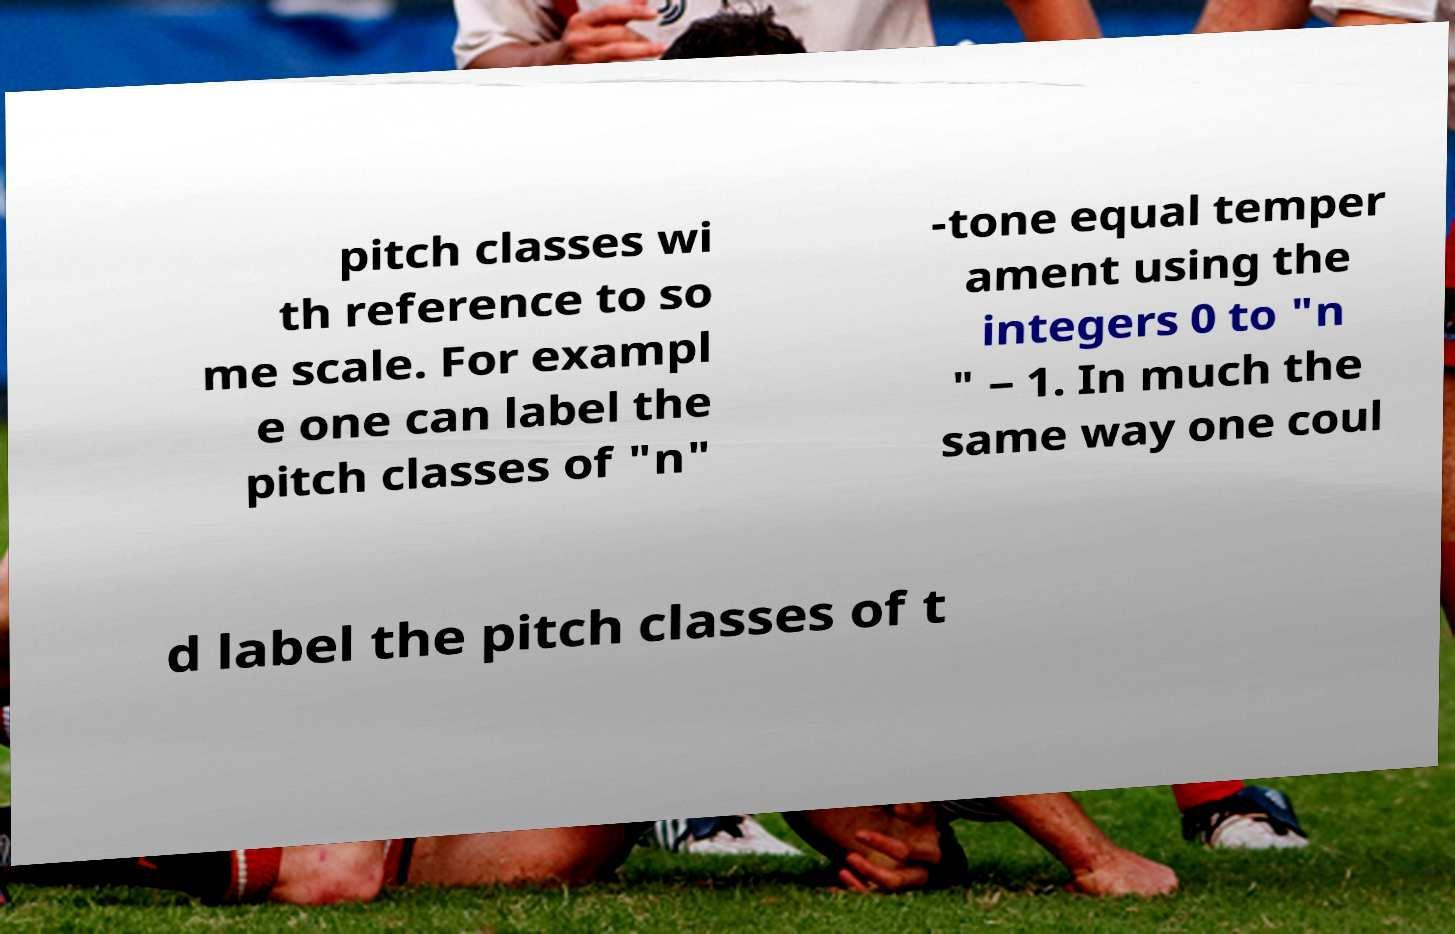I need the written content from this picture converted into text. Can you do that? pitch classes wi th reference to so me scale. For exampl e one can label the pitch classes of "n" -tone equal temper ament using the integers 0 to "n " − 1. In much the same way one coul d label the pitch classes of t 